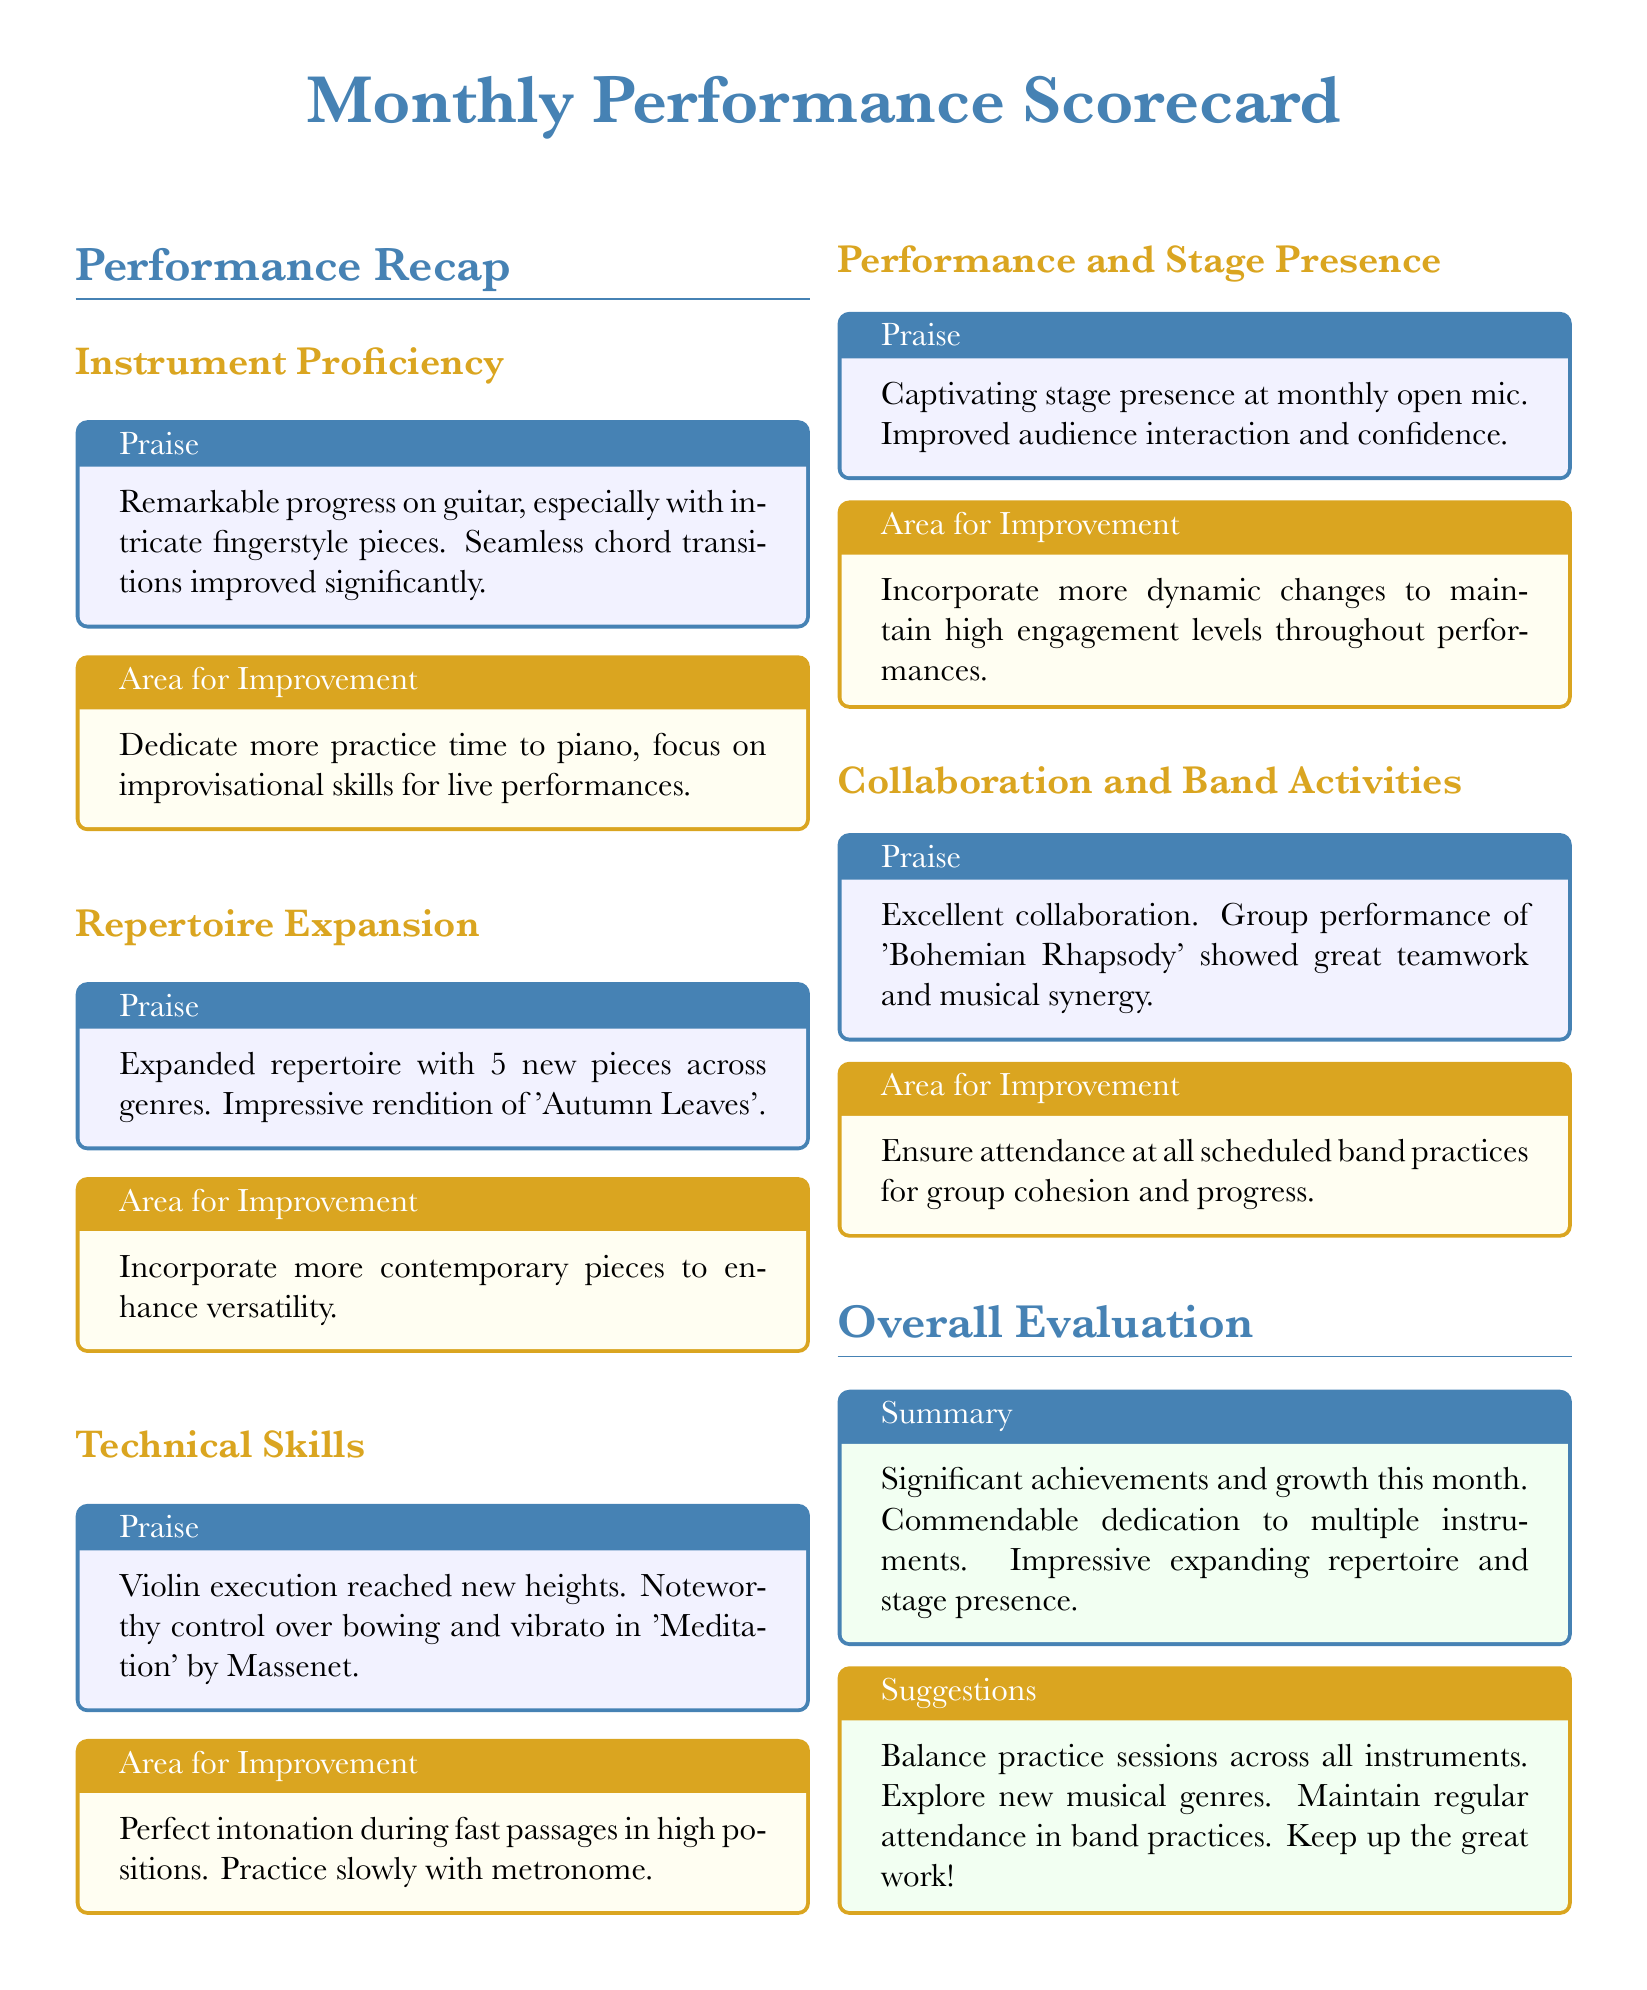What is the title of the document? The title at the center of the document indicates the nature of the contents, focusing on monthly performance evaluation.
Answer: Monthly Performance Scorecard How many new pieces were added to the repertoire? The document specifies the number of new pieces added in the Repertoire Expansion section.
Answer: 5 What instrument showed remarkable progress? The document highlights a specific instrument that exhibited significant improvement in its proficiency.
Answer: Guitar What is an area for improvement mentioned for piano? The document lists particular skills to focus on in relation to the piano instrument.
Answer: Improvisational skills What was highlighted as a notable performance piece on violin? The document provides a title of a specific piece that exemplified exceptional execution on the violin.
Answer: Meditation by Massenet What was praised about the stage presence during performances? The document describes the quality of the individual's stage presence during performances at an event.
Answer: Captivating stage presence What area for improvement is mentioned regarding collaboration and band activities? The document suggests an aspect to work on to enhance collaboration within band activities.
Answer: Ensure attendance at all scheduled band practices What color is used for the praise sections throughout the document? The document corresponds certain colors to praise categories, which can be identified throughout its sections.
Answer: Blue What is the overall evaluation's summary note? The overall evaluation section provides a summary note that encapsulates the achievements and growth mentioned.
Answer: Significant achievements and growth this month 